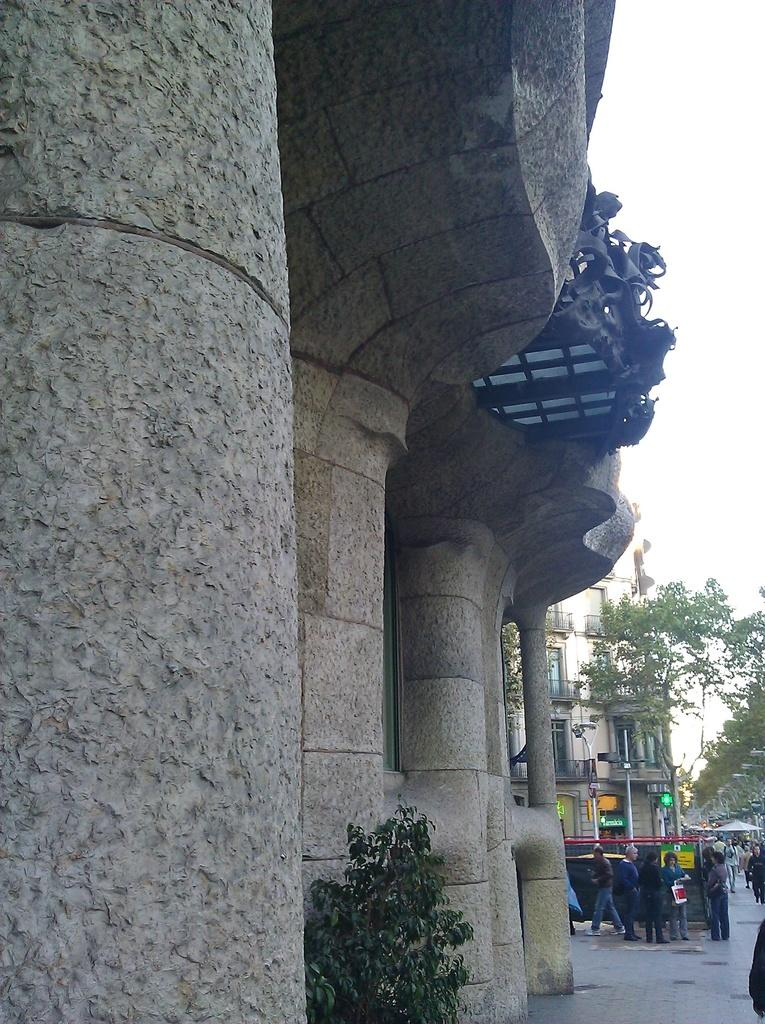What type of structure is located on the left side of the image? There is a building with pillars on the left side of the image. What is situated near the building? There is a plant near the building. What can be seen in the background of the image? There are many people, another building, and trees in the background of the image. What type of string is being played by the guitarist in the image? There is no guitar or guitarist present in the image. 